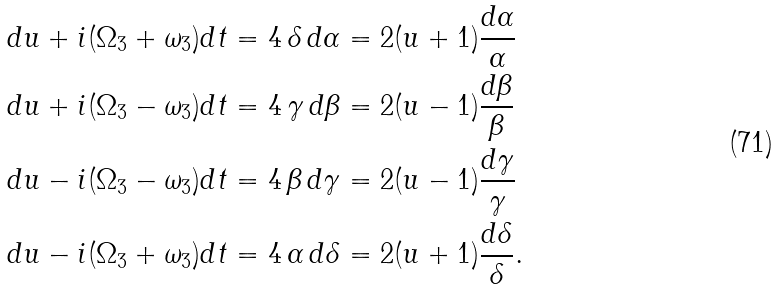Convert formula to latex. <formula><loc_0><loc_0><loc_500><loc_500>d u + i ( \Omega _ { 3 } + \omega _ { 3 } ) d t & = 4 \, \delta \, d \alpha = 2 ( u + 1 ) \frac { d \alpha } { \alpha } \\ d u + i ( \Omega _ { 3 } - \omega _ { 3 } ) d t & = 4 \, \gamma \, d \beta = 2 ( u - 1 ) \frac { d \beta } { \beta } \\ d u - i ( \Omega _ { 3 } - \omega _ { 3 } ) d t & = 4 \, \beta \, d \gamma = 2 ( u - 1 ) \frac { d \gamma } { \gamma } \\ d u - i ( \Omega _ { 3 } + \omega _ { 3 } ) d t & = 4 \, \alpha \, d \delta = 2 ( u + 1 ) \frac { d \delta } { \delta } .</formula> 